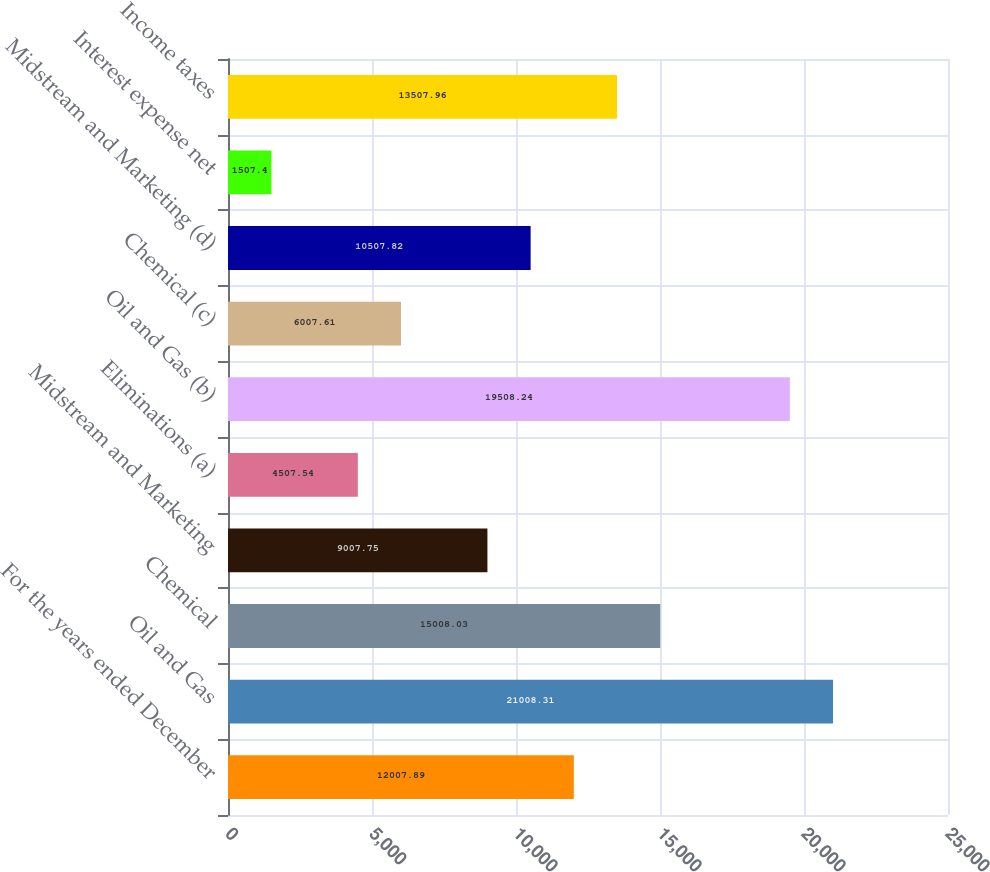<chart> <loc_0><loc_0><loc_500><loc_500><bar_chart><fcel>For the years ended December<fcel>Oil and Gas<fcel>Chemical<fcel>Midstream and Marketing<fcel>Eliminations (a)<fcel>Oil and Gas (b)<fcel>Chemical (c)<fcel>Midstream and Marketing (d)<fcel>Interest expense net<fcel>Income taxes<nl><fcel>12007.9<fcel>21008.3<fcel>15008<fcel>9007.75<fcel>4507.54<fcel>19508.2<fcel>6007.61<fcel>10507.8<fcel>1507.4<fcel>13508<nl></chart> 